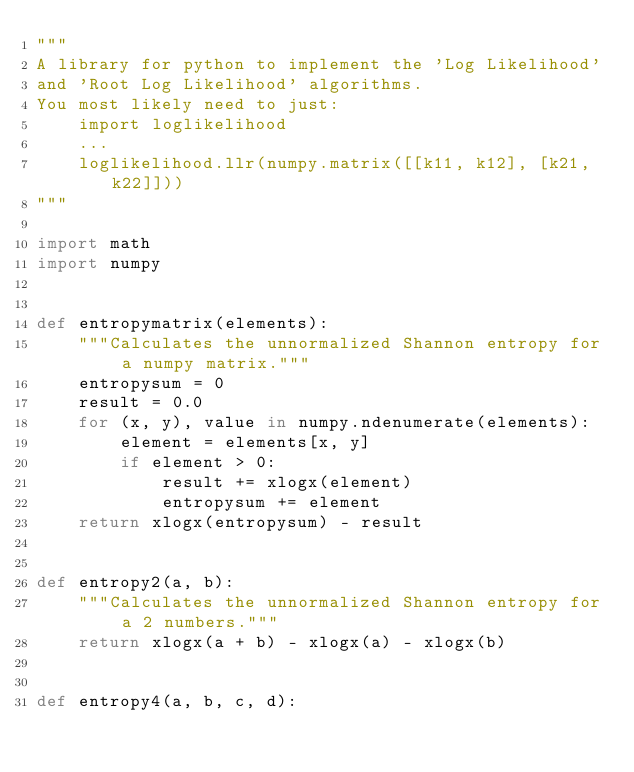Convert code to text. <code><loc_0><loc_0><loc_500><loc_500><_Python_>"""
A library for python to implement the 'Log Likelihood'
and 'Root Log Likelihood' algorithms.
You most likely need to just:
    import loglikelihood
    ...
    loglikelihood.llr(numpy.matrix([[k11, k12], [k21, k22]]))
"""

import math
import numpy


def entropymatrix(elements):
    """Calculates the unnormalized Shannon entropy for a numpy matrix."""
    entropysum = 0
    result = 0.0
    for (x, y), value in numpy.ndenumerate(elements):
        element = elements[x, y]
        if element > 0:
            result += xlogx(element)
            entropysum += element
    return xlogx(entropysum) - result


def entropy2(a, b):
    """Calculates the unnormalized Shannon entropy for a 2 numbers."""
    return xlogx(a + b) - xlogx(a) - xlogx(b)


def entropy4(a, b, c, d):</code> 